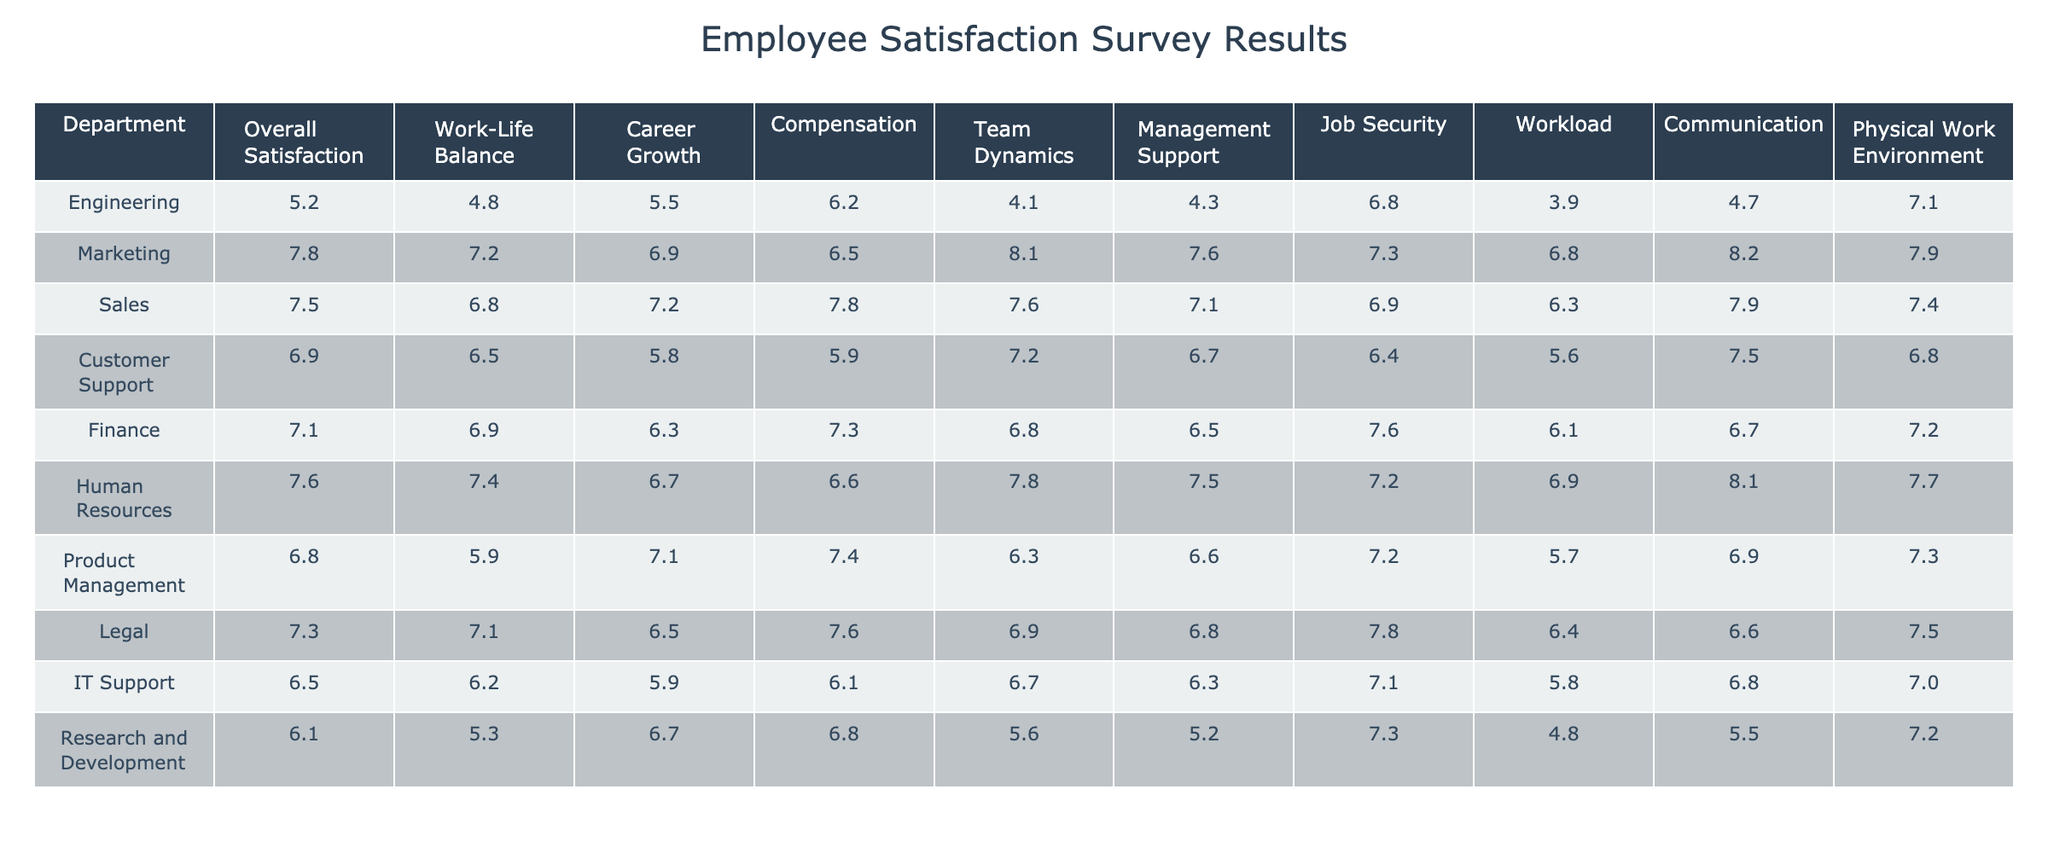What is the overall satisfaction score of the Engineering department? The overall satisfaction score for the Engineering department is listed directly in the table under the corresponding column. It shows a score of 5.2.
Answer: 5.2 Which department has the highest score in Work-Life Balance? By reviewing the Work-Life Balance scores, Marketing has the highest score of 7.2, compared to the other departments.
Answer: 7.2 What is the average score for Career Growth across all departments? To find the average score, sum all Career Growth values: 5.5 + 6.9 + 7.2 + 5.8 + 6.3 + 6.7 + 7.1 + 6.5 + 6.7 + 6.7 = 64.5. There are 10 departments, so the average is 64.5 / 10 = 6.45.
Answer: 6.45 Is the Compensation score for the Engineering department higher than that for Customer Support? The Compensation score for Engineering is 6.2, and for Customer Support, it is 5.9. Since 6.2 is greater than 5.9, it confirms that Engineering's score is indeed higher.
Answer: Yes Which department has the lowest score in Team Dynamics? By examining the Team Dynamics scores, Engineering has the lowest score of 4.1 when compared to all other departments.
Answer: 4.1 If we compare the Communication scores of Finance and Human Resources, which department scores higher? The Communication score for Finance is 6.7, while for Human Resources, it is 8.1. Since 8.1 is greater than 6.7, Human Resources scores higher in this category.
Answer: Human Resources What is the difference between the Job Security scores of Engineering and IT Support? The Job Security score for Engineering is 6.8, and for IT Support, it is 7.1. To find the difference, subtract: 7.1 - 6.8 = 0.3.
Answer: 0.3 Which department has the best score in Physical Work Environment? When looking at the Physical Work Environment column, Marketing has the highest score of 7.9 compared to the other departments.
Answer: 7.9 What are the two departments that have the closest Overall Satisfaction scores? The Overall Satisfaction scores for Sales (7.5) and Finance (7.1) are relatively close compared to the other departments with scores, making them the closest pair.
Answer: Sales and Finance Is the Workload score of Research and Development lower than that of Engineering? The workload score for Research and Development is 4.8, while for Engineering, it is 3.9. Since 4.8 is greater than 3.9, it is false that Research and Development has a lower workload score.
Answer: No 